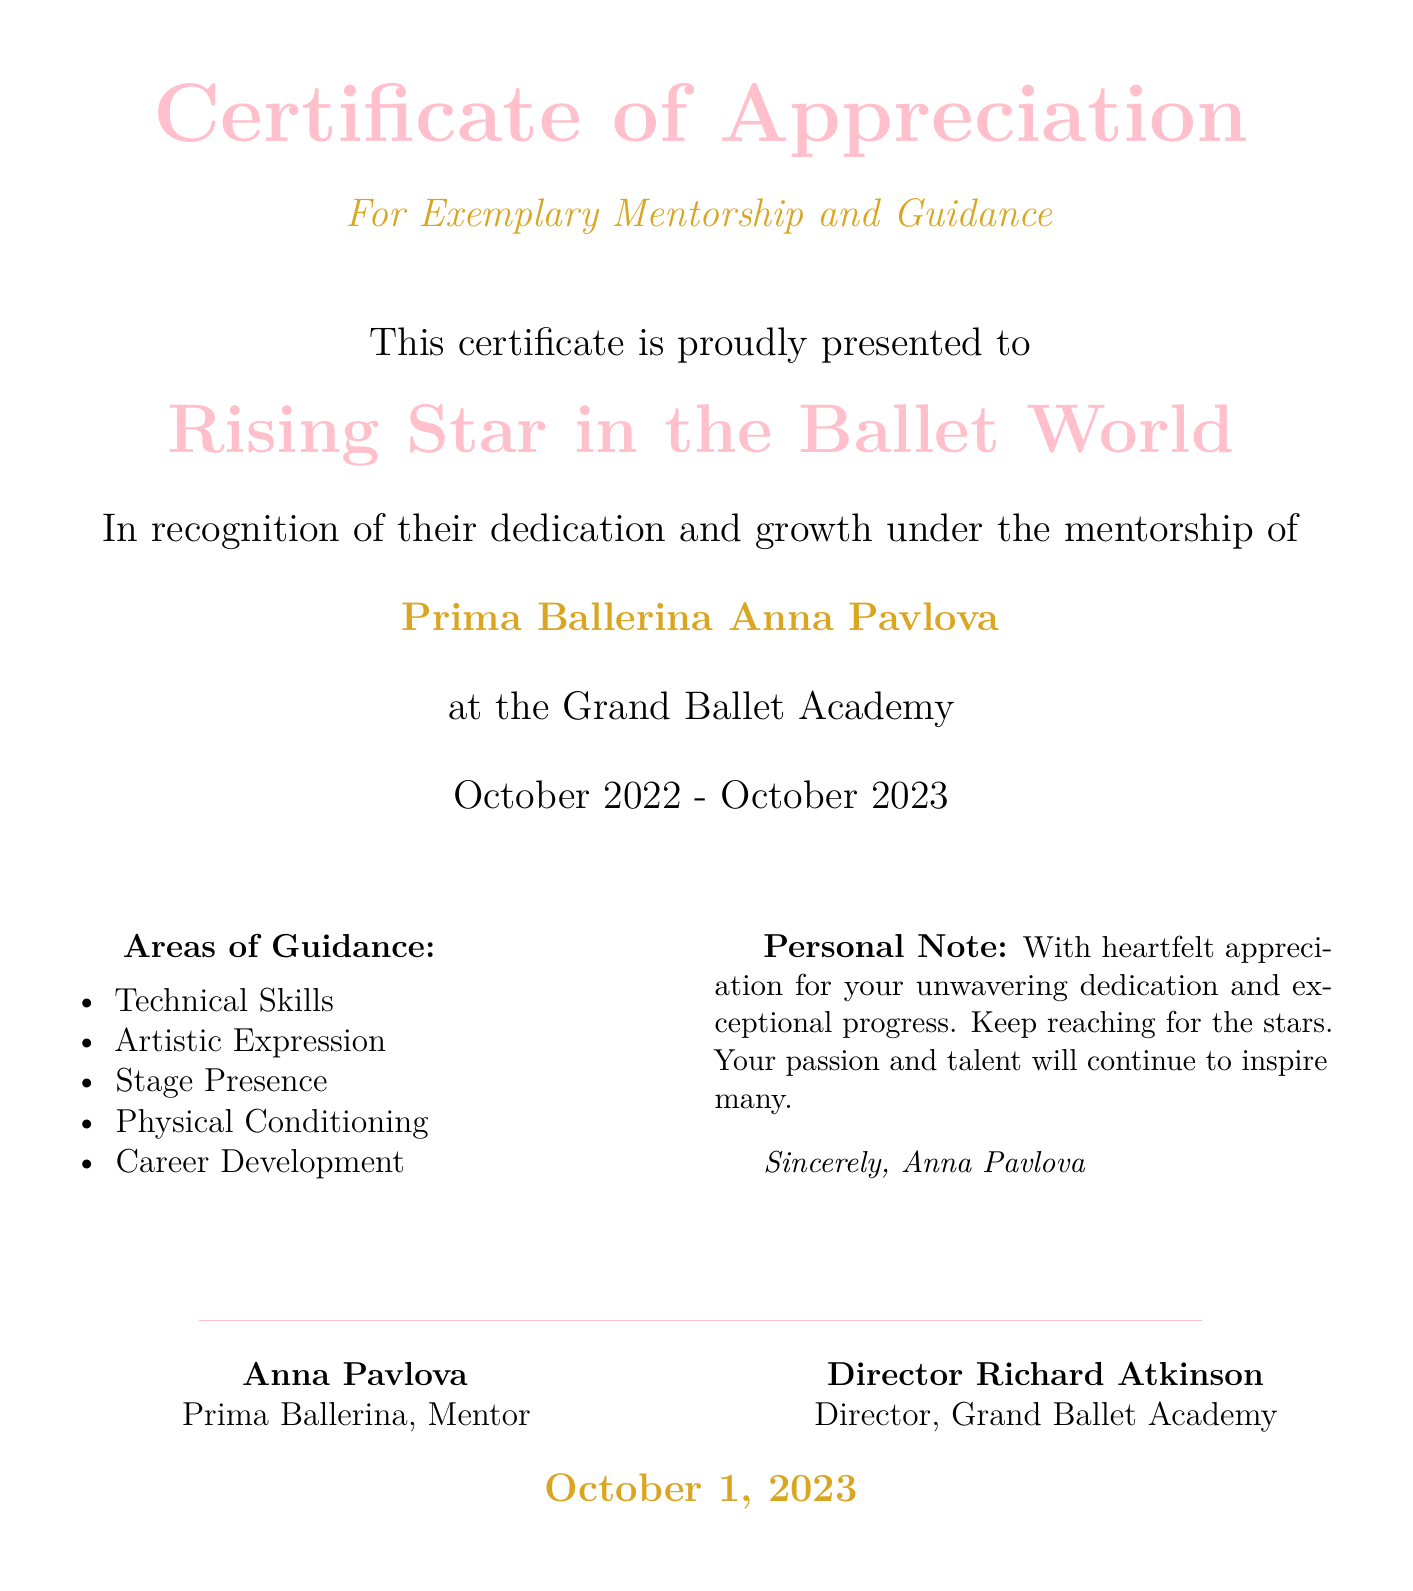What is the title of the certificate? The title of the certificate is prominently displayed at the top, identifying it as a Certificate of Appreciation.
Answer: Certificate of Appreciation Who is the recipient of the certificate? The recipient's name is mentioned as "Rising Star in the Ballet World."
Answer: Rising Star in the Ballet World Who provided the mentorship? The mentor's name is listed prominently under the recipient's name.
Answer: Prima Ballerina Anna Pavlova What is the duration of the mentorship? The duration of mentorship is specified in a date range format in the document.
Answer: October 2022 - October 2023 What are two areas of guidance mentioned? The document lists multiple areas of guidance, any two listed are acceptable.
Answer: Technical Skills, Artistic Expression What personal note does the mentor include? The mentor's personal note emphasizes dedication and progress.
Answer: With heartfelt appreciation for your unwavering dedication and exceptional progress What is the purpose of this certificate? The purpose is clearly defined at the beginning of the document.
Answer: For Exemplary Mentorship and Guidance Who is the director of the Grand Ballet Academy? The director's name is mentioned next to their title in the certificate.
Answer: Director Richard Atkinson What color is used for the certificate's title? The color used for the title is described in the document.
Answer: balletpink 